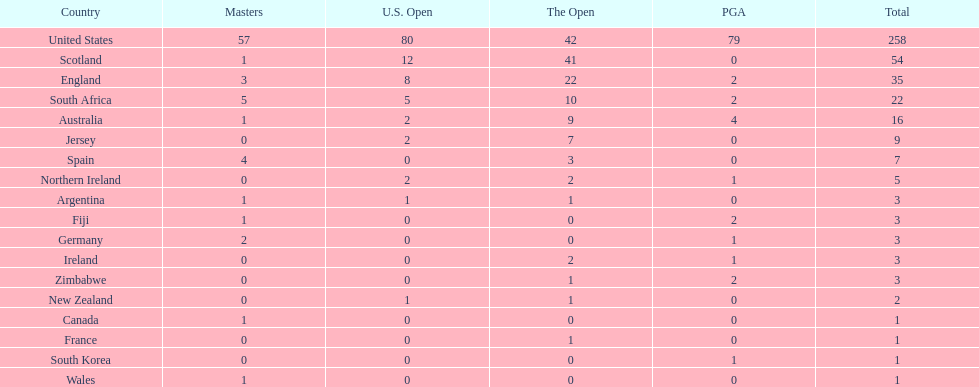What are the number of pga winning golfers that zimbabwe has? 2. 